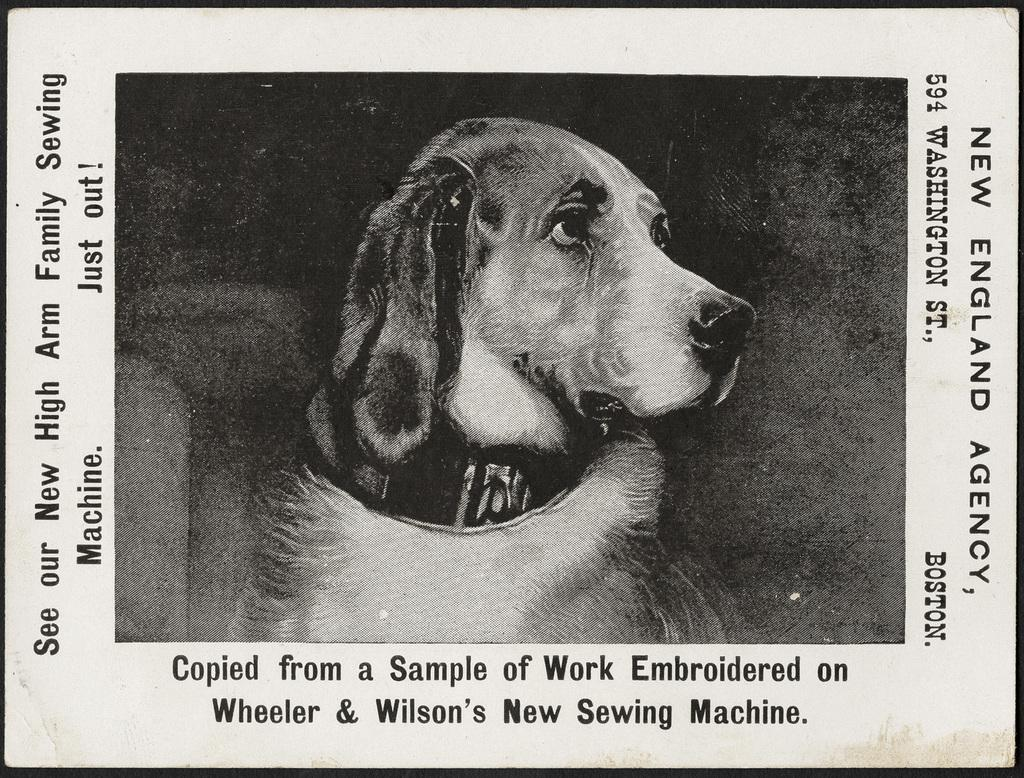What is the main object in the image? There is a paper in the image. What else can be seen in the center of the image? There is a dog in the center of the image. Can you read any text in the image? Yes, there is text visible in the image. What type of cushion is the dog sitting on in the image? There is no cushion present in the image; the dog is in the center of the image without any visible cushion. 